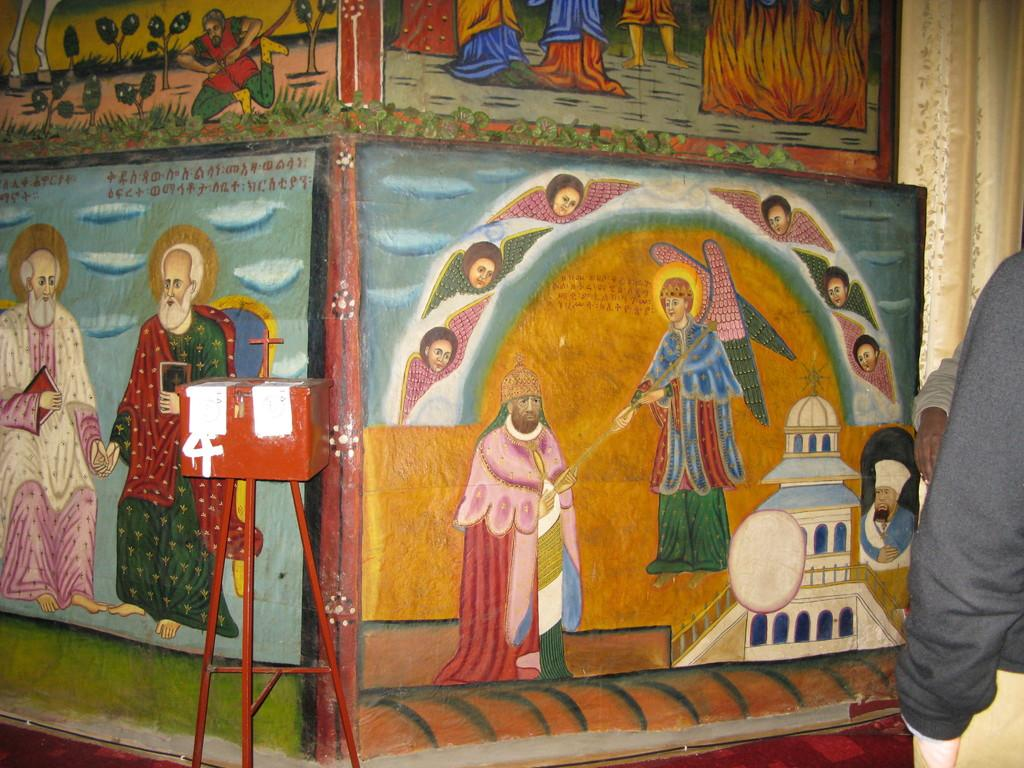What is depicted on the wall in the image? There is a painting of humans on the wall. What can be seen on the right side of the image? There are humans standing on the right side of the image. What object is present on a stand in the image? There is a metal box on a stand in the image. Are there any whips visible in the image? No, there are no whips present in the image. Can you see any horses in the image? No, there are no horses present in the image. 